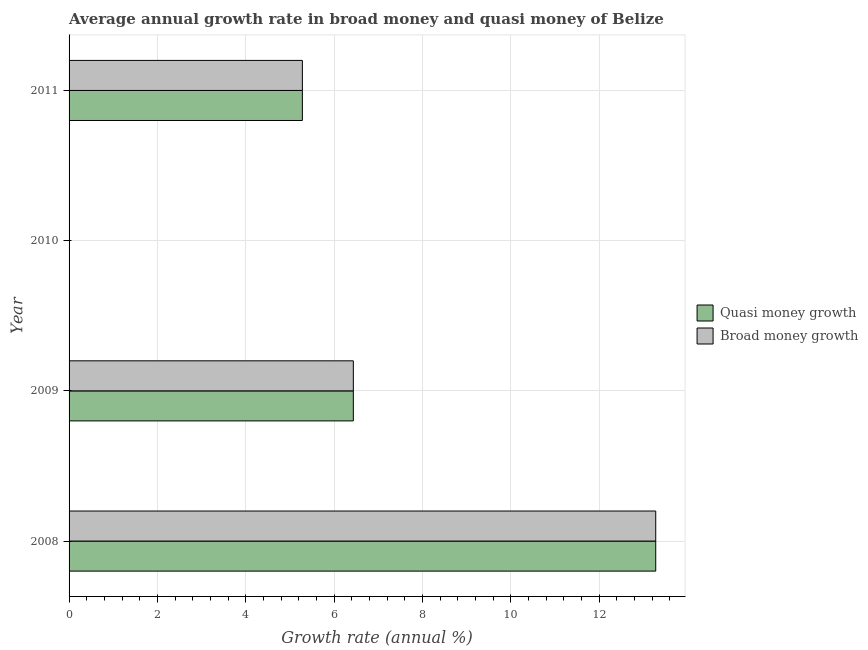Are the number of bars per tick equal to the number of legend labels?
Your response must be concise. No. Are the number of bars on each tick of the Y-axis equal?
Provide a succinct answer. No. In how many cases, is the number of bars for a given year not equal to the number of legend labels?
Your answer should be compact. 1. What is the annual growth rate in quasi money in 2010?
Your answer should be compact. 0. Across all years, what is the maximum annual growth rate in quasi money?
Your response must be concise. 13.28. What is the total annual growth rate in broad money in the graph?
Offer a terse response. 24.99. What is the difference between the annual growth rate in quasi money in 2008 and that in 2009?
Give a very brief answer. 6.84. What is the difference between the annual growth rate in quasi money in 2011 and the annual growth rate in broad money in 2009?
Offer a terse response. -1.15. What is the average annual growth rate in broad money per year?
Provide a short and direct response. 6.25. In how many years, is the annual growth rate in quasi money greater than 2 %?
Your answer should be very brief. 3. What is the ratio of the annual growth rate in broad money in 2009 to that in 2011?
Your response must be concise. 1.22. Is the annual growth rate in broad money in 2008 less than that in 2011?
Offer a very short reply. No. What is the difference between the highest and the second highest annual growth rate in quasi money?
Your response must be concise. 6.84. What is the difference between the highest and the lowest annual growth rate in quasi money?
Offer a very short reply. 13.28. In how many years, is the annual growth rate in broad money greater than the average annual growth rate in broad money taken over all years?
Provide a short and direct response. 2. How many bars are there?
Offer a terse response. 6. How many years are there in the graph?
Give a very brief answer. 4. What is the difference between two consecutive major ticks on the X-axis?
Your response must be concise. 2. Does the graph contain any zero values?
Make the answer very short. Yes. Where does the legend appear in the graph?
Your response must be concise. Center right. How many legend labels are there?
Your answer should be compact. 2. What is the title of the graph?
Keep it short and to the point. Average annual growth rate in broad money and quasi money of Belize. What is the label or title of the X-axis?
Your answer should be very brief. Growth rate (annual %). What is the label or title of the Y-axis?
Your answer should be very brief. Year. What is the Growth rate (annual %) in Quasi money growth in 2008?
Ensure brevity in your answer.  13.28. What is the Growth rate (annual %) of Broad money growth in 2008?
Your response must be concise. 13.28. What is the Growth rate (annual %) in Quasi money growth in 2009?
Your answer should be compact. 6.43. What is the Growth rate (annual %) in Broad money growth in 2009?
Your answer should be compact. 6.43. What is the Growth rate (annual %) in Quasi money growth in 2011?
Your response must be concise. 5.28. What is the Growth rate (annual %) of Broad money growth in 2011?
Provide a short and direct response. 5.28. Across all years, what is the maximum Growth rate (annual %) of Quasi money growth?
Provide a succinct answer. 13.28. Across all years, what is the maximum Growth rate (annual %) of Broad money growth?
Ensure brevity in your answer.  13.28. Across all years, what is the minimum Growth rate (annual %) of Quasi money growth?
Offer a terse response. 0. Across all years, what is the minimum Growth rate (annual %) in Broad money growth?
Make the answer very short. 0. What is the total Growth rate (annual %) of Quasi money growth in the graph?
Give a very brief answer. 24.99. What is the total Growth rate (annual %) in Broad money growth in the graph?
Keep it short and to the point. 24.99. What is the difference between the Growth rate (annual %) of Quasi money growth in 2008 and that in 2009?
Make the answer very short. 6.84. What is the difference between the Growth rate (annual %) of Broad money growth in 2008 and that in 2009?
Make the answer very short. 6.84. What is the difference between the Growth rate (annual %) of Quasi money growth in 2008 and that in 2011?
Your answer should be very brief. 8. What is the difference between the Growth rate (annual %) of Broad money growth in 2008 and that in 2011?
Give a very brief answer. 8. What is the difference between the Growth rate (annual %) of Quasi money growth in 2009 and that in 2011?
Your response must be concise. 1.15. What is the difference between the Growth rate (annual %) of Broad money growth in 2009 and that in 2011?
Offer a terse response. 1.15. What is the difference between the Growth rate (annual %) in Quasi money growth in 2008 and the Growth rate (annual %) in Broad money growth in 2009?
Offer a terse response. 6.84. What is the difference between the Growth rate (annual %) in Quasi money growth in 2008 and the Growth rate (annual %) in Broad money growth in 2011?
Provide a short and direct response. 8. What is the difference between the Growth rate (annual %) in Quasi money growth in 2009 and the Growth rate (annual %) in Broad money growth in 2011?
Make the answer very short. 1.15. What is the average Growth rate (annual %) of Quasi money growth per year?
Provide a succinct answer. 6.25. What is the average Growth rate (annual %) of Broad money growth per year?
Your answer should be compact. 6.25. In the year 2008, what is the difference between the Growth rate (annual %) in Quasi money growth and Growth rate (annual %) in Broad money growth?
Make the answer very short. 0. What is the ratio of the Growth rate (annual %) of Quasi money growth in 2008 to that in 2009?
Your answer should be compact. 2.06. What is the ratio of the Growth rate (annual %) of Broad money growth in 2008 to that in 2009?
Your answer should be compact. 2.06. What is the ratio of the Growth rate (annual %) of Quasi money growth in 2008 to that in 2011?
Your answer should be compact. 2.51. What is the ratio of the Growth rate (annual %) of Broad money growth in 2008 to that in 2011?
Your answer should be very brief. 2.51. What is the ratio of the Growth rate (annual %) of Quasi money growth in 2009 to that in 2011?
Keep it short and to the point. 1.22. What is the ratio of the Growth rate (annual %) of Broad money growth in 2009 to that in 2011?
Your answer should be very brief. 1.22. What is the difference between the highest and the second highest Growth rate (annual %) in Quasi money growth?
Make the answer very short. 6.84. What is the difference between the highest and the second highest Growth rate (annual %) in Broad money growth?
Give a very brief answer. 6.84. What is the difference between the highest and the lowest Growth rate (annual %) of Quasi money growth?
Keep it short and to the point. 13.28. What is the difference between the highest and the lowest Growth rate (annual %) of Broad money growth?
Make the answer very short. 13.28. 